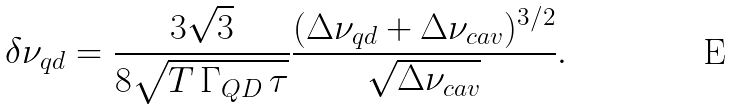<formula> <loc_0><loc_0><loc_500><loc_500>\delta \nu _ { q d } = \frac { 3 \sqrt { 3 } } { 8 \sqrt { T \, \Gamma _ { Q D } \, \tau } } \frac { ( \Delta \nu _ { q d } + \Delta \nu _ { c a v } ) ^ { 3 / 2 } } { \sqrt { \Delta \nu _ { c a v } } } .</formula> 